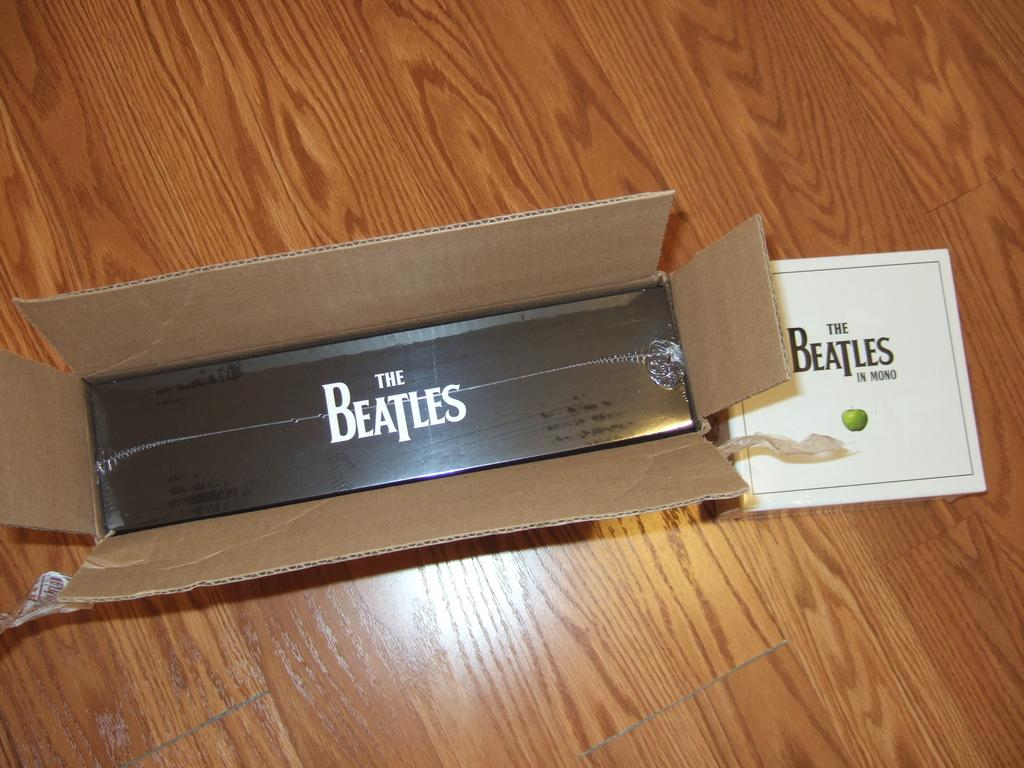<image>
Write a terse but informative summary of the picture. A box that has been opened showing the content to be Beatles products. 